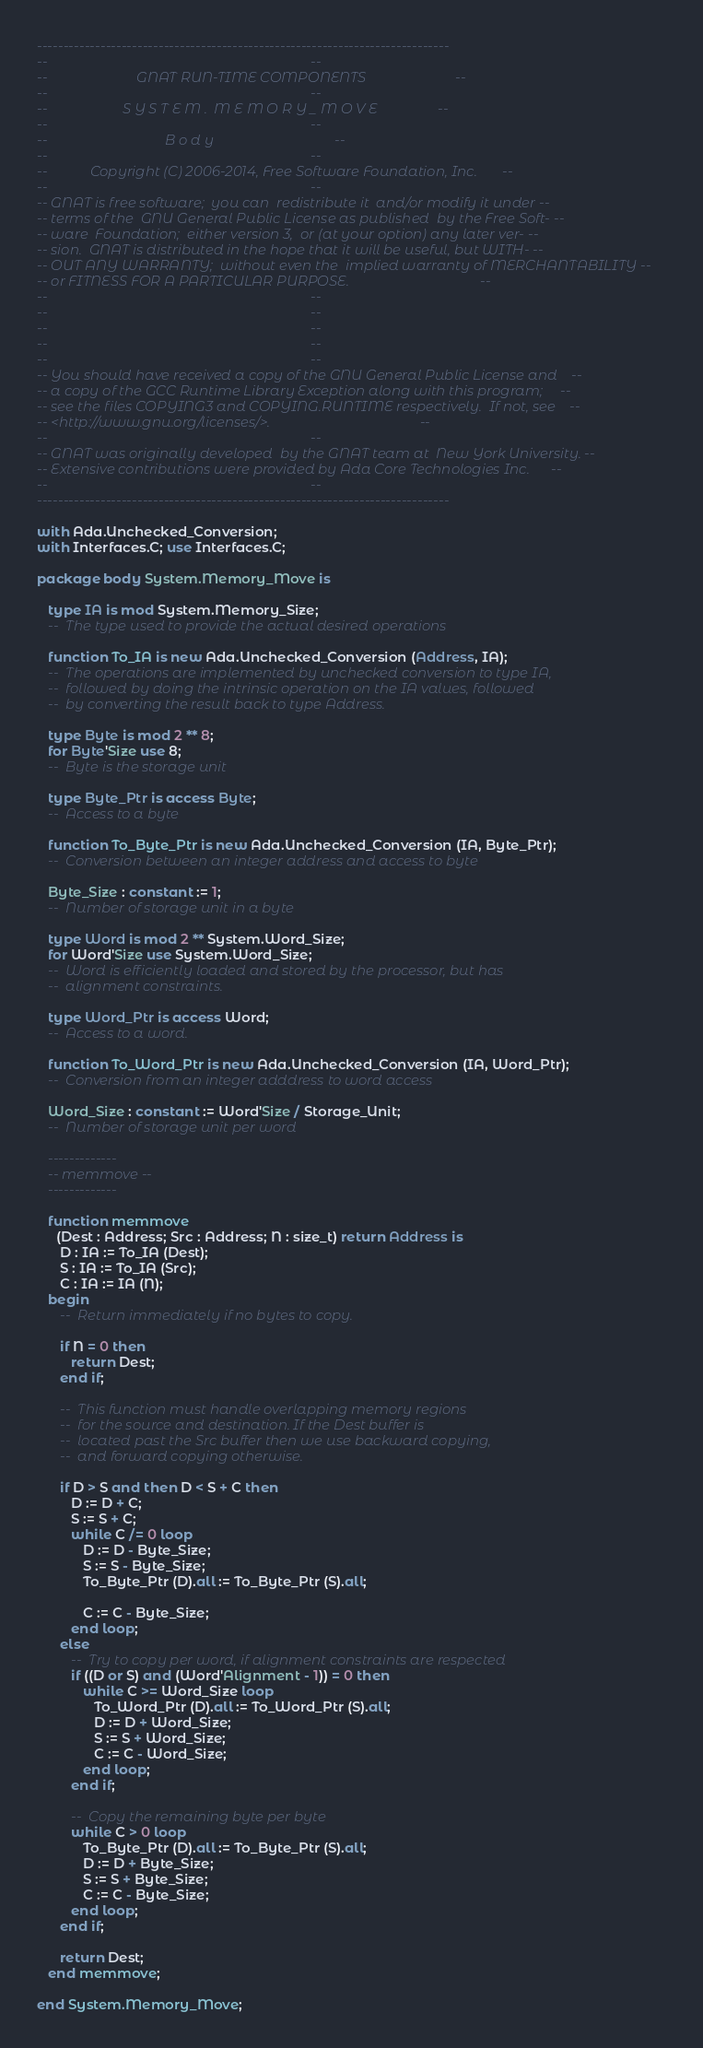Convert code to text. <code><loc_0><loc_0><loc_500><loc_500><_Ada_>------------------------------------------------------------------------------
--                                                                          --
--                         GNAT RUN-TIME COMPONENTS                         --
--                                                                          --
--                     S Y S T E M .  M E M O R Y _ M O V E                 --
--                                                                          --
--                                 B o d y                                  --
--                                                                          --
--            Copyright (C) 2006-2014, Free Software Foundation, Inc.       --
--                                                                          --
-- GNAT is free software;  you can  redistribute it  and/or modify it under --
-- terms of the  GNU General Public License as published  by the Free Soft- --
-- ware  Foundation;  either version 3,  or (at your option) any later ver- --
-- sion.  GNAT is distributed in the hope that it will be useful, but WITH- --
-- OUT ANY WARRANTY;  without even the  implied warranty of MERCHANTABILITY --
-- or FITNESS FOR A PARTICULAR PURPOSE.                                     --
--                                                                          --
--                                                                          --
--                                                                          --
--                                                                          --
--                                                                          --
-- You should have received a copy of the GNU General Public License and    --
-- a copy of the GCC Runtime Library Exception along with this program;     --
-- see the files COPYING3 and COPYING.RUNTIME respectively.  If not, see    --
-- <http://www.gnu.org/licenses/>.                                          --
--                                                                          --
-- GNAT was originally developed  by the GNAT team at  New York University. --
-- Extensive contributions were provided by Ada Core Technologies Inc.      --
--                                                                          --
------------------------------------------------------------------------------

with Ada.Unchecked_Conversion;
with Interfaces.C; use Interfaces.C;

package body System.Memory_Move is

   type IA is mod System.Memory_Size;
   --  The type used to provide the actual desired operations

   function To_IA is new Ada.Unchecked_Conversion (Address, IA);
   --  The operations are implemented by unchecked conversion to type IA,
   --  followed by doing the intrinsic operation on the IA values, followed
   --  by converting the result back to type Address.

   type Byte is mod 2 ** 8;
   for Byte'Size use 8;
   --  Byte is the storage unit

   type Byte_Ptr is access Byte;
   --  Access to a byte

   function To_Byte_Ptr is new Ada.Unchecked_Conversion (IA, Byte_Ptr);
   --  Conversion between an integer address and access to byte

   Byte_Size : constant := 1;
   --  Number of storage unit in a byte

   type Word is mod 2 ** System.Word_Size;
   for Word'Size use System.Word_Size;
   --  Word is efficiently loaded and stored by the processor, but has
   --  alignment constraints.

   type Word_Ptr is access Word;
   --  Access to a word.

   function To_Word_Ptr is new Ada.Unchecked_Conversion (IA, Word_Ptr);
   --  Conversion from an integer adddress to word access

   Word_Size : constant := Word'Size / Storage_Unit;
   --  Number of storage unit per word

   -------------
   -- memmove --
   -------------

   function memmove
     (Dest : Address; Src : Address; N : size_t) return Address is
      D : IA := To_IA (Dest);
      S : IA := To_IA (Src);
      C : IA := IA (N);
   begin
      --  Return immediately if no bytes to copy.

      if N = 0 then
         return Dest;
      end if;

      --  This function must handle overlapping memory regions
      --  for the source and destination. If the Dest buffer is
      --  located past the Src buffer then we use backward copying,
      --  and forward copying otherwise.

      if D > S and then D < S + C then
         D := D + C;
         S := S + C;
         while C /= 0 loop
            D := D - Byte_Size;
            S := S - Byte_Size;
            To_Byte_Ptr (D).all := To_Byte_Ptr (S).all;

            C := C - Byte_Size;
         end loop;
      else
         --  Try to copy per word, if alignment constraints are respected
         if ((D or S) and (Word'Alignment - 1)) = 0 then
            while C >= Word_Size loop
               To_Word_Ptr (D).all := To_Word_Ptr (S).all;
               D := D + Word_Size;
               S := S + Word_Size;
               C := C - Word_Size;
            end loop;
         end if;

         --  Copy the remaining byte per byte
         while C > 0 loop
            To_Byte_Ptr (D).all := To_Byte_Ptr (S).all;
            D := D + Byte_Size;
            S := S + Byte_Size;
            C := C - Byte_Size;
         end loop;
      end if;

      return Dest;
   end memmove;

end System.Memory_Move;
</code> 